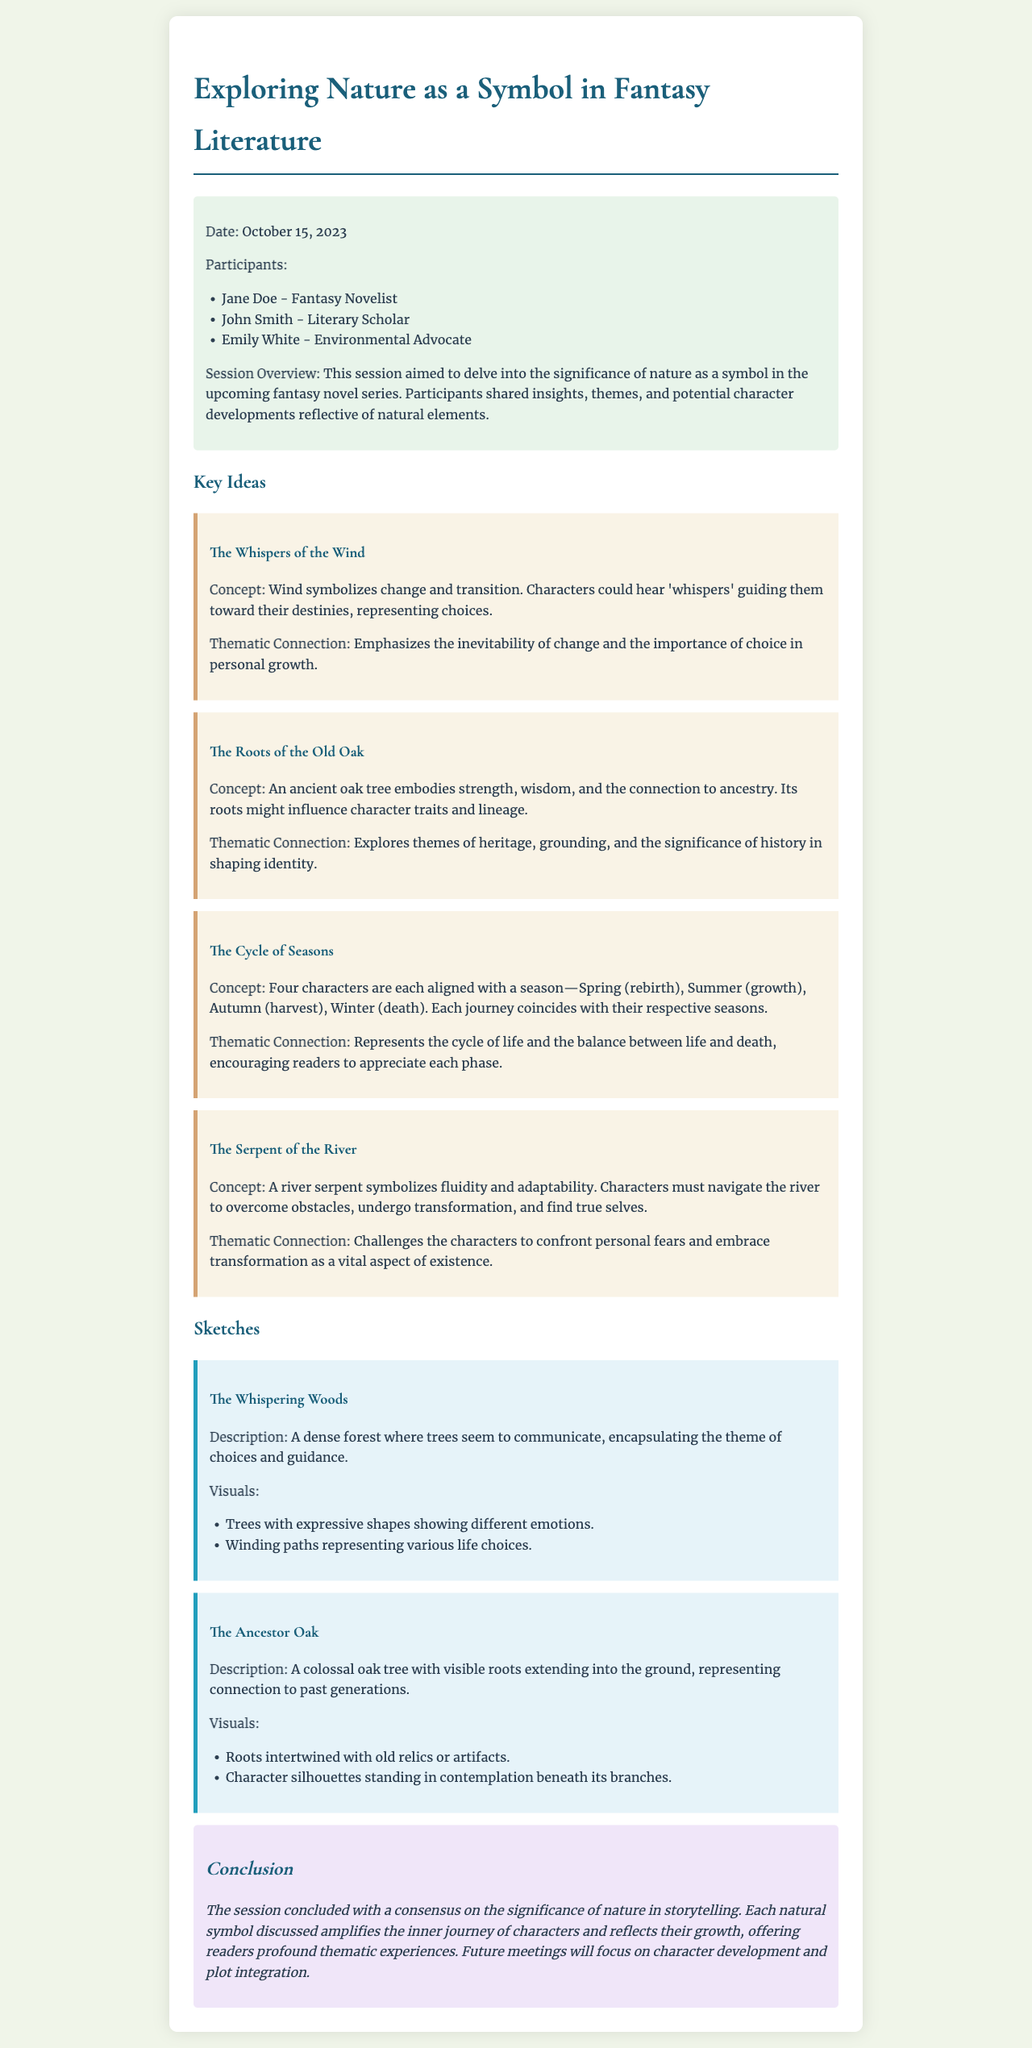What is the date of the brainstorming session? The date is explicitly mentioned in the session info as October 15, 2023.
Answer: October 15, 2023 Who is one of the participants in the session? The document lists three participants, one of whom is Jane Doe, a fantasy novelist.
Answer: Jane Doe What symbolizes change and transition in the novel? The document refers to wind as a symbol of change and transition in the key ideas section.
Answer: Wind How many characters are aligned with the seasons? The document states that there are four characters, each aligned with a season.
Answer: Four What is the title of the section discussing sketches? The title directly indicates that it is about "Sketches" as a thematic section in the document.
Answer: Sketches What natural element embodies strength and wisdom? The document describes the ancient oak tree as embodying strength and wisdom.
Answer: Oak tree What theme is associated with The Serpent of the River? The document details that it symbolizes fluidity and adaptability, presenting a key theme.
Answer: Fluidity and adaptability What conclusion did the session reach regarding nature? The concluding statement emphasizes the significance of nature in storytelling.
Answer: Significance of nature in storytelling 